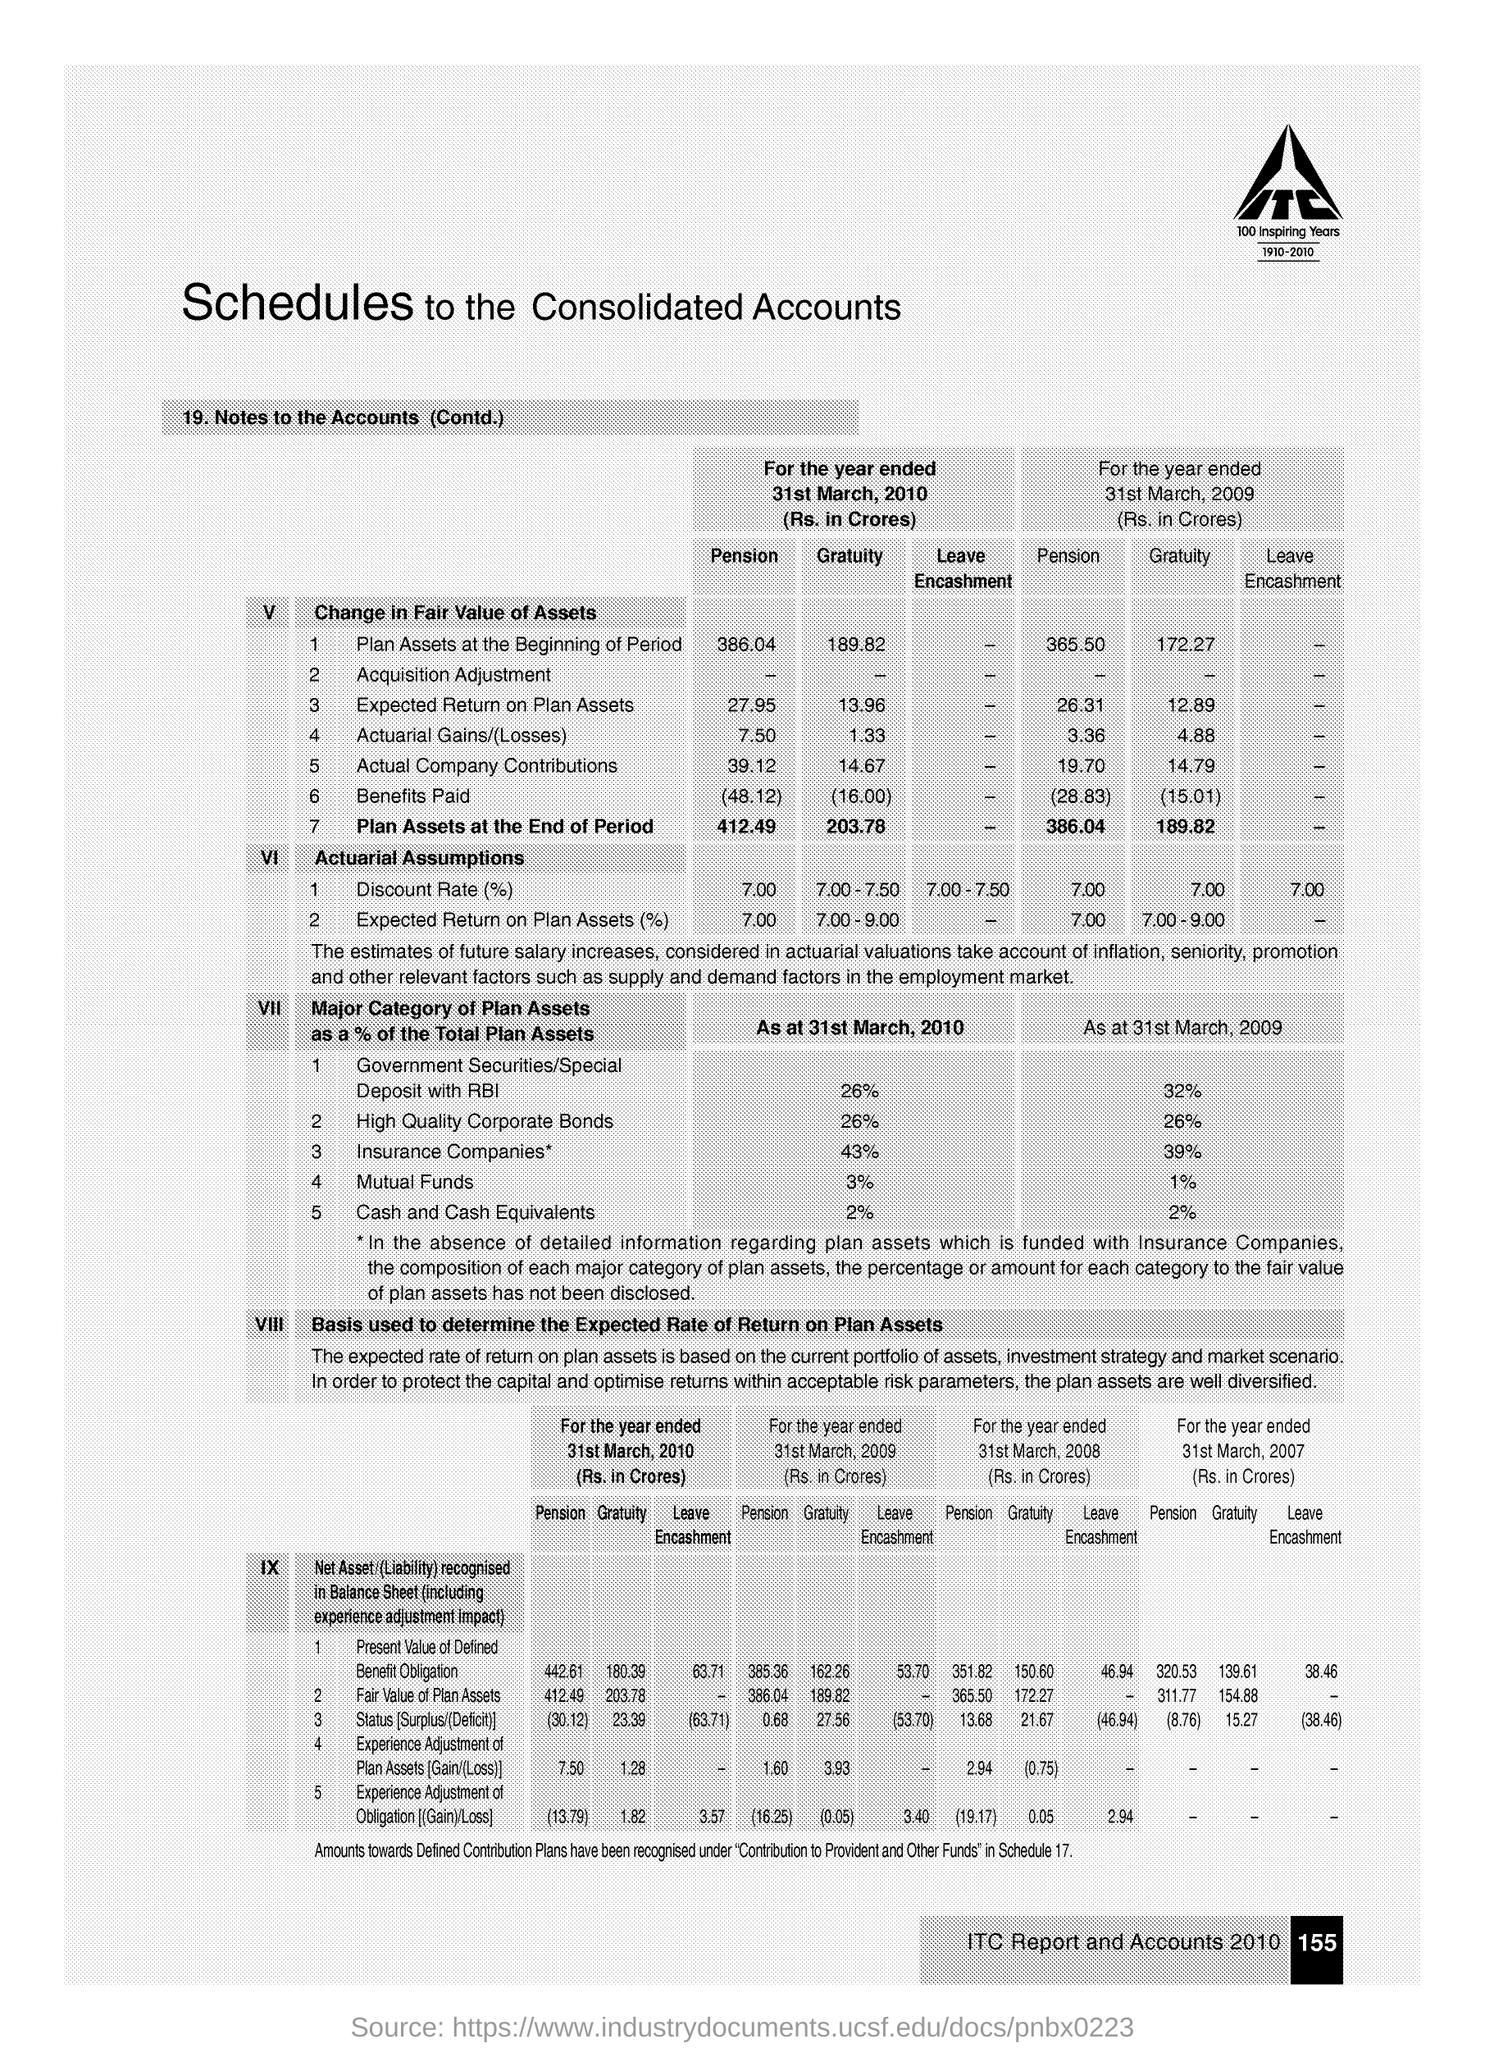Point out several critical features in this image. The unit of pension for Actuarial Gains/(Losses) for the year ended in 2010 was 7.50. As of March 31, 2009, mutual funds constituted approximately 1% of the total plan assets in the United States. 